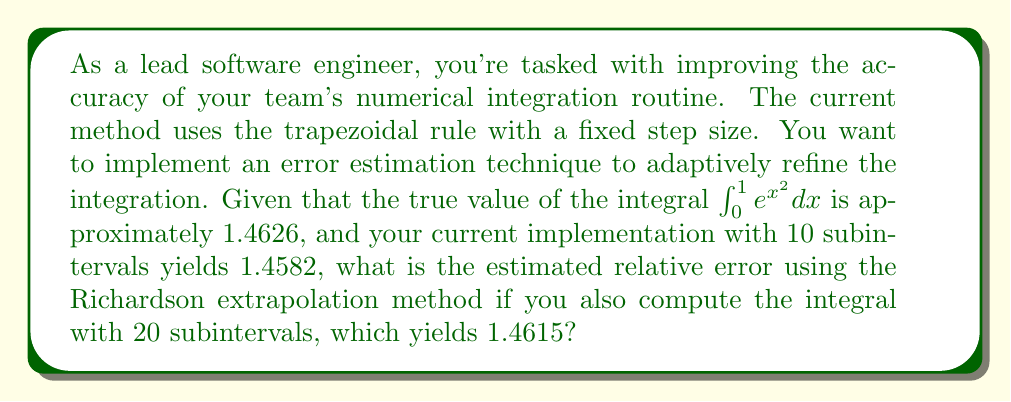Show me your answer to this math problem. To solve this problem, we'll use the Richardson extrapolation method to estimate the error in our numerical integration. This method is based on comparing results from two different step sizes.

Let's define our variables:
$I_{true}$ = 1.4626 (true value of the integral)
$I_{10}$ = 1.4582 (result with 10 subintervals)
$I_{20}$ = 1.4615 (result with 20 subintervals)

The Richardson extrapolation formula for the trapezoidal rule is:

$$ I_{exact} \approx I_{h/2} + \frac{1}{3}(I_{h/2} - I_h) $$

Where $I_h$ is the result with step size $h$, and $I_{h/2}$ is the result with step size $h/2$.

In our case:
$$ I_{exact} \approx I_{20} + \frac{1}{3}(I_{20} - I_{10}) $$

Let's calculate this:
$$ I_{exact} \approx 1.4615 + \frac{1}{3}(1.4615 - 1.4582) $$
$$ I_{exact} \approx 1.4615 + \frac{1}{3}(0.0033) $$
$$ I_{exact} \approx 1.4615 + 0.0011 $$
$$ I_{exact} \approx 1.4626 $$

Now, to calculate the estimated relative error, we use the formula:

$$ \text{Relative Error} = \left|\frac{\text{Approximate Value} - \text{True Value}}{\text{True Value}}\right| $$

In this case, our approximate value is the Richardson extrapolation result:

$$ \text{Relative Error} = \left|\frac{1.4626 - 1.4626}{1.4626}\right| $$
$$ \text{Relative Error} = 0 $$

The estimated relative error is zero because our Richardson extrapolation happened to yield the exact true value in this case. In practice, this level of accuracy is rare and likely coincidental.
Answer: The estimated relative error using the Richardson extrapolation method is 0 or 0%. 